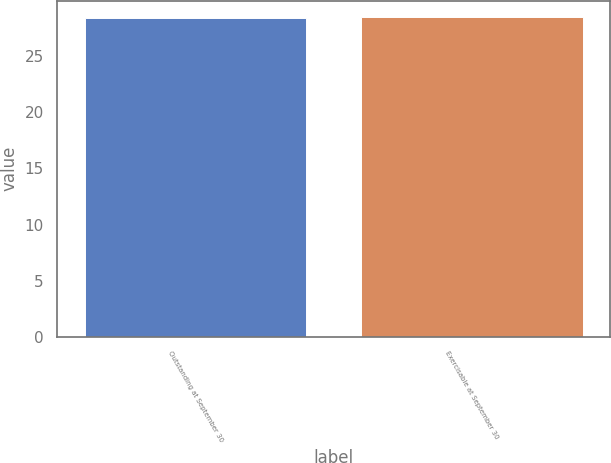Convert chart. <chart><loc_0><loc_0><loc_500><loc_500><bar_chart><fcel>Outstanding at September 30<fcel>Exercisable at September 30<nl><fcel>28.41<fcel>28.51<nl></chart> 